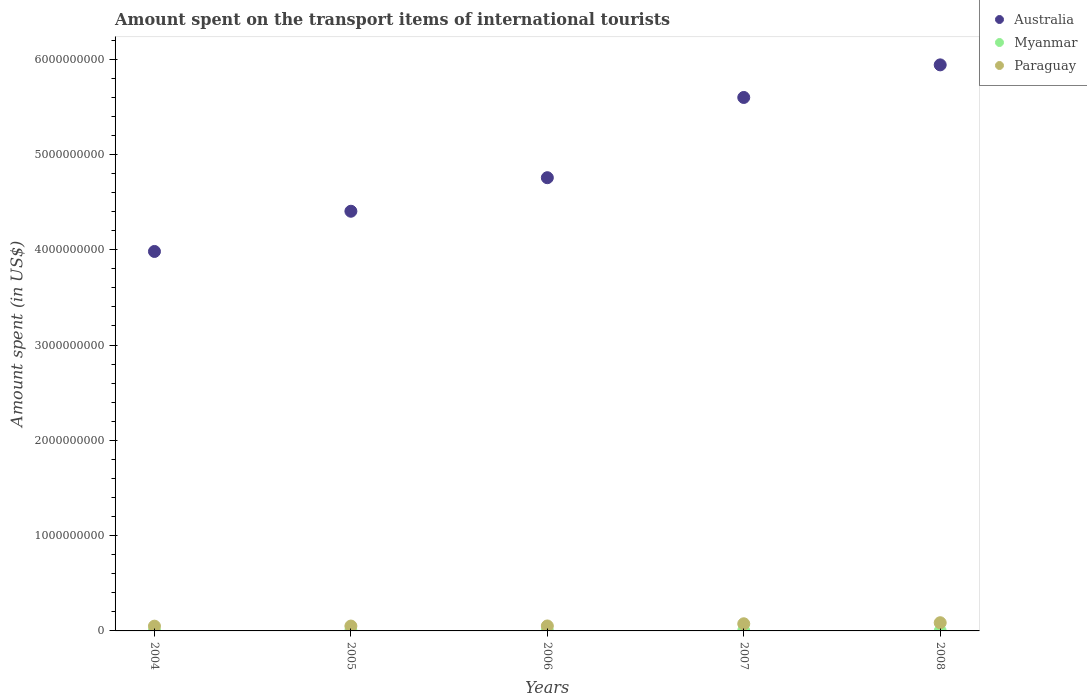In which year was the amount spent on the transport items of international tourists in Australia maximum?
Ensure brevity in your answer.  2008. What is the total amount spent on the transport items of international tourists in Australia in the graph?
Your response must be concise. 2.47e+1. What is the difference between the amount spent on the transport items of international tourists in Australia in 2005 and that in 2007?
Keep it short and to the point. -1.19e+09. What is the difference between the amount spent on the transport items of international tourists in Australia in 2004 and the amount spent on the transport items of international tourists in Paraguay in 2008?
Give a very brief answer. 3.90e+09. What is the average amount spent on the transport items of international tourists in Myanmar per year?
Your response must be concise. 2.54e+06. In the year 2007, what is the difference between the amount spent on the transport items of international tourists in Paraguay and amount spent on the transport items of international tourists in Australia?
Your answer should be very brief. -5.52e+09. In how many years, is the amount spent on the transport items of international tourists in Paraguay greater than 4600000000 US$?
Offer a terse response. 0. What is the ratio of the amount spent on the transport items of international tourists in Myanmar in 2005 to that in 2007?
Make the answer very short. 1. Is the difference between the amount spent on the transport items of international tourists in Paraguay in 2005 and 2007 greater than the difference between the amount spent on the transport items of international tourists in Australia in 2005 and 2007?
Offer a terse response. Yes. What is the difference between the highest and the second highest amount spent on the transport items of international tourists in Australia?
Provide a short and direct response. 3.42e+08. What is the difference between the highest and the lowest amount spent on the transport items of international tourists in Australia?
Provide a short and direct response. 1.96e+09. Is the sum of the amount spent on the transport items of international tourists in Australia in 2005 and 2007 greater than the maximum amount spent on the transport items of international tourists in Myanmar across all years?
Make the answer very short. Yes. How many years are there in the graph?
Keep it short and to the point. 5. What is the difference between two consecutive major ticks on the Y-axis?
Offer a terse response. 1.00e+09. How many legend labels are there?
Make the answer very short. 3. How are the legend labels stacked?
Your response must be concise. Vertical. What is the title of the graph?
Offer a terse response. Amount spent on the transport items of international tourists. What is the label or title of the X-axis?
Keep it short and to the point. Years. What is the label or title of the Y-axis?
Your answer should be very brief. Amount spent (in US$). What is the Amount spent (in US$) of Australia in 2004?
Ensure brevity in your answer.  3.98e+09. What is the Amount spent (in US$) of Australia in 2005?
Keep it short and to the point. 4.40e+09. What is the Amount spent (in US$) in Myanmar in 2005?
Keep it short and to the point. 3.00e+06. What is the Amount spent (in US$) in Paraguay in 2005?
Make the answer very short. 5.10e+07. What is the Amount spent (in US$) of Australia in 2006?
Your answer should be compact. 4.76e+09. What is the Amount spent (in US$) in Paraguay in 2006?
Provide a succinct answer. 5.20e+07. What is the Amount spent (in US$) of Australia in 2007?
Keep it short and to the point. 5.60e+09. What is the Amount spent (in US$) in Paraguay in 2007?
Make the answer very short. 7.50e+07. What is the Amount spent (in US$) of Australia in 2008?
Offer a terse response. 5.94e+09. What is the Amount spent (in US$) of Myanmar in 2008?
Provide a short and direct response. 7.00e+05. What is the Amount spent (in US$) of Paraguay in 2008?
Keep it short and to the point. 8.60e+07. Across all years, what is the maximum Amount spent (in US$) in Australia?
Offer a very short reply. 5.94e+09. Across all years, what is the maximum Amount spent (in US$) in Paraguay?
Offer a terse response. 8.60e+07. Across all years, what is the minimum Amount spent (in US$) in Australia?
Your answer should be very brief. 3.98e+09. Across all years, what is the minimum Amount spent (in US$) of Myanmar?
Your answer should be compact. 7.00e+05. Across all years, what is the minimum Amount spent (in US$) in Paraguay?
Make the answer very short. 5.00e+07. What is the total Amount spent (in US$) of Australia in the graph?
Offer a terse response. 2.47e+1. What is the total Amount spent (in US$) in Myanmar in the graph?
Make the answer very short. 1.27e+07. What is the total Amount spent (in US$) of Paraguay in the graph?
Offer a very short reply. 3.14e+08. What is the difference between the Amount spent (in US$) in Australia in 2004 and that in 2005?
Offer a terse response. -4.22e+08. What is the difference between the Amount spent (in US$) in Myanmar in 2004 and that in 2005?
Ensure brevity in your answer.  0. What is the difference between the Amount spent (in US$) in Australia in 2004 and that in 2006?
Your answer should be compact. -7.74e+08. What is the difference between the Amount spent (in US$) in Myanmar in 2004 and that in 2006?
Offer a very short reply. 0. What is the difference between the Amount spent (in US$) in Australia in 2004 and that in 2007?
Your response must be concise. -1.62e+09. What is the difference between the Amount spent (in US$) of Paraguay in 2004 and that in 2007?
Offer a terse response. -2.50e+07. What is the difference between the Amount spent (in US$) in Australia in 2004 and that in 2008?
Your answer should be compact. -1.96e+09. What is the difference between the Amount spent (in US$) of Myanmar in 2004 and that in 2008?
Offer a terse response. 2.30e+06. What is the difference between the Amount spent (in US$) of Paraguay in 2004 and that in 2008?
Provide a succinct answer. -3.60e+07. What is the difference between the Amount spent (in US$) of Australia in 2005 and that in 2006?
Your answer should be compact. -3.52e+08. What is the difference between the Amount spent (in US$) in Paraguay in 2005 and that in 2006?
Give a very brief answer. -1.00e+06. What is the difference between the Amount spent (in US$) in Australia in 2005 and that in 2007?
Offer a terse response. -1.19e+09. What is the difference between the Amount spent (in US$) of Myanmar in 2005 and that in 2007?
Your answer should be compact. 0. What is the difference between the Amount spent (in US$) in Paraguay in 2005 and that in 2007?
Offer a terse response. -2.40e+07. What is the difference between the Amount spent (in US$) in Australia in 2005 and that in 2008?
Ensure brevity in your answer.  -1.54e+09. What is the difference between the Amount spent (in US$) in Myanmar in 2005 and that in 2008?
Your answer should be compact. 2.30e+06. What is the difference between the Amount spent (in US$) in Paraguay in 2005 and that in 2008?
Ensure brevity in your answer.  -3.50e+07. What is the difference between the Amount spent (in US$) in Australia in 2006 and that in 2007?
Give a very brief answer. -8.42e+08. What is the difference between the Amount spent (in US$) in Myanmar in 2006 and that in 2007?
Offer a terse response. 0. What is the difference between the Amount spent (in US$) in Paraguay in 2006 and that in 2007?
Your answer should be very brief. -2.30e+07. What is the difference between the Amount spent (in US$) in Australia in 2006 and that in 2008?
Make the answer very short. -1.18e+09. What is the difference between the Amount spent (in US$) of Myanmar in 2006 and that in 2008?
Your answer should be compact. 2.30e+06. What is the difference between the Amount spent (in US$) in Paraguay in 2006 and that in 2008?
Provide a short and direct response. -3.40e+07. What is the difference between the Amount spent (in US$) of Australia in 2007 and that in 2008?
Provide a succinct answer. -3.42e+08. What is the difference between the Amount spent (in US$) in Myanmar in 2007 and that in 2008?
Your answer should be compact. 2.30e+06. What is the difference between the Amount spent (in US$) of Paraguay in 2007 and that in 2008?
Keep it short and to the point. -1.10e+07. What is the difference between the Amount spent (in US$) in Australia in 2004 and the Amount spent (in US$) in Myanmar in 2005?
Your response must be concise. 3.98e+09. What is the difference between the Amount spent (in US$) of Australia in 2004 and the Amount spent (in US$) of Paraguay in 2005?
Offer a very short reply. 3.93e+09. What is the difference between the Amount spent (in US$) of Myanmar in 2004 and the Amount spent (in US$) of Paraguay in 2005?
Provide a succinct answer. -4.80e+07. What is the difference between the Amount spent (in US$) of Australia in 2004 and the Amount spent (in US$) of Myanmar in 2006?
Keep it short and to the point. 3.98e+09. What is the difference between the Amount spent (in US$) of Australia in 2004 and the Amount spent (in US$) of Paraguay in 2006?
Provide a short and direct response. 3.93e+09. What is the difference between the Amount spent (in US$) in Myanmar in 2004 and the Amount spent (in US$) in Paraguay in 2006?
Provide a succinct answer. -4.90e+07. What is the difference between the Amount spent (in US$) in Australia in 2004 and the Amount spent (in US$) in Myanmar in 2007?
Offer a very short reply. 3.98e+09. What is the difference between the Amount spent (in US$) of Australia in 2004 and the Amount spent (in US$) of Paraguay in 2007?
Offer a very short reply. 3.91e+09. What is the difference between the Amount spent (in US$) of Myanmar in 2004 and the Amount spent (in US$) of Paraguay in 2007?
Offer a very short reply. -7.20e+07. What is the difference between the Amount spent (in US$) of Australia in 2004 and the Amount spent (in US$) of Myanmar in 2008?
Make the answer very short. 3.98e+09. What is the difference between the Amount spent (in US$) in Australia in 2004 and the Amount spent (in US$) in Paraguay in 2008?
Your response must be concise. 3.90e+09. What is the difference between the Amount spent (in US$) in Myanmar in 2004 and the Amount spent (in US$) in Paraguay in 2008?
Provide a succinct answer. -8.30e+07. What is the difference between the Amount spent (in US$) in Australia in 2005 and the Amount spent (in US$) in Myanmar in 2006?
Offer a very short reply. 4.40e+09. What is the difference between the Amount spent (in US$) in Australia in 2005 and the Amount spent (in US$) in Paraguay in 2006?
Your response must be concise. 4.35e+09. What is the difference between the Amount spent (in US$) in Myanmar in 2005 and the Amount spent (in US$) in Paraguay in 2006?
Your response must be concise. -4.90e+07. What is the difference between the Amount spent (in US$) of Australia in 2005 and the Amount spent (in US$) of Myanmar in 2007?
Your answer should be compact. 4.40e+09. What is the difference between the Amount spent (in US$) in Australia in 2005 and the Amount spent (in US$) in Paraguay in 2007?
Provide a short and direct response. 4.33e+09. What is the difference between the Amount spent (in US$) of Myanmar in 2005 and the Amount spent (in US$) of Paraguay in 2007?
Keep it short and to the point. -7.20e+07. What is the difference between the Amount spent (in US$) in Australia in 2005 and the Amount spent (in US$) in Myanmar in 2008?
Give a very brief answer. 4.40e+09. What is the difference between the Amount spent (in US$) of Australia in 2005 and the Amount spent (in US$) of Paraguay in 2008?
Give a very brief answer. 4.32e+09. What is the difference between the Amount spent (in US$) in Myanmar in 2005 and the Amount spent (in US$) in Paraguay in 2008?
Offer a terse response. -8.30e+07. What is the difference between the Amount spent (in US$) in Australia in 2006 and the Amount spent (in US$) in Myanmar in 2007?
Provide a succinct answer. 4.75e+09. What is the difference between the Amount spent (in US$) of Australia in 2006 and the Amount spent (in US$) of Paraguay in 2007?
Provide a short and direct response. 4.68e+09. What is the difference between the Amount spent (in US$) in Myanmar in 2006 and the Amount spent (in US$) in Paraguay in 2007?
Ensure brevity in your answer.  -7.20e+07. What is the difference between the Amount spent (in US$) in Australia in 2006 and the Amount spent (in US$) in Myanmar in 2008?
Provide a short and direct response. 4.76e+09. What is the difference between the Amount spent (in US$) of Australia in 2006 and the Amount spent (in US$) of Paraguay in 2008?
Give a very brief answer. 4.67e+09. What is the difference between the Amount spent (in US$) in Myanmar in 2006 and the Amount spent (in US$) in Paraguay in 2008?
Provide a short and direct response. -8.30e+07. What is the difference between the Amount spent (in US$) of Australia in 2007 and the Amount spent (in US$) of Myanmar in 2008?
Make the answer very short. 5.60e+09. What is the difference between the Amount spent (in US$) in Australia in 2007 and the Amount spent (in US$) in Paraguay in 2008?
Provide a succinct answer. 5.51e+09. What is the difference between the Amount spent (in US$) of Myanmar in 2007 and the Amount spent (in US$) of Paraguay in 2008?
Keep it short and to the point. -8.30e+07. What is the average Amount spent (in US$) in Australia per year?
Your response must be concise. 4.94e+09. What is the average Amount spent (in US$) in Myanmar per year?
Your answer should be compact. 2.54e+06. What is the average Amount spent (in US$) in Paraguay per year?
Provide a short and direct response. 6.28e+07. In the year 2004, what is the difference between the Amount spent (in US$) of Australia and Amount spent (in US$) of Myanmar?
Give a very brief answer. 3.98e+09. In the year 2004, what is the difference between the Amount spent (in US$) in Australia and Amount spent (in US$) in Paraguay?
Make the answer very short. 3.93e+09. In the year 2004, what is the difference between the Amount spent (in US$) in Myanmar and Amount spent (in US$) in Paraguay?
Give a very brief answer. -4.70e+07. In the year 2005, what is the difference between the Amount spent (in US$) of Australia and Amount spent (in US$) of Myanmar?
Provide a succinct answer. 4.40e+09. In the year 2005, what is the difference between the Amount spent (in US$) in Australia and Amount spent (in US$) in Paraguay?
Keep it short and to the point. 4.35e+09. In the year 2005, what is the difference between the Amount spent (in US$) in Myanmar and Amount spent (in US$) in Paraguay?
Keep it short and to the point. -4.80e+07. In the year 2006, what is the difference between the Amount spent (in US$) of Australia and Amount spent (in US$) of Myanmar?
Provide a short and direct response. 4.75e+09. In the year 2006, what is the difference between the Amount spent (in US$) in Australia and Amount spent (in US$) in Paraguay?
Offer a very short reply. 4.70e+09. In the year 2006, what is the difference between the Amount spent (in US$) of Myanmar and Amount spent (in US$) of Paraguay?
Keep it short and to the point. -4.90e+07. In the year 2007, what is the difference between the Amount spent (in US$) of Australia and Amount spent (in US$) of Myanmar?
Give a very brief answer. 5.60e+09. In the year 2007, what is the difference between the Amount spent (in US$) in Australia and Amount spent (in US$) in Paraguay?
Provide a succinct answer. 5.52e+09. In the year 2007, what is the difference between the Amount spent (in US$) of Myanmar and Amount spent (in US$) of Paraguay?
Ensure brevity in your answer.  -7.20e+07. In the year 2008, what is the difference between the Amount spent (in US$) in Australia and Amount spent (in US$) in Myanmar?
Make the answer very short. 5.94e+09. In the year 2008, what is the difference between the Amount spent (in US$) in Australia and Amount spent (in US$) in Paraguay?
Offer a very short reply. 5.85e+09. In the year 2008, what is the difference between the Amount spent (in US$) in Myanmar and Amount spent (in US$) in Paraguay?
Offer a terse response. -8.53e+07. What is the ratio of the Amount spent (in US$) in Australia in 2004 to that in 2005?
Provide a short and direct response. 0.9. What is the ratio of the Amount spent (in US$) of Myanmar in 2004 to that in 2005?
Make the answer very short. 1. What is the ratio of the Amount spent (in US$) in Paraguay in 2004 to that in 2005?
Offer a terse response. 0.98. What is the ratio of the Amount spent (in US$) in Australia in 2004 to that in 2006?
Your answer should be very brief. 0.84. What is the ratio of the Amount spent (in US$) of Myanmar in 2004 to that in 2006?
Offer a very short reply. 1. What is the ratio of the Amount spent (in US$) in Paraguay in 2004 to that in 2006?
Offer a terse response. 0.96. What is the ratio of the Amount spent (in US$) of Australia in 2004 to that in 2007?
Provide a short and direct response. 0.71. What is the ratio of the Amount spent (in US$) of Myanmar in 2004 to that in 2007?
Give a very brief answer. 1. What is the ratio of the Amount spent (in US$) in Paraguay in 2004 to that in 2007?
Your answer should be compact. 0.67. What is the ratio of the Amount spent (in US$) of Australia in 2004 to that in 2008?
Make the answer very short. 0.67. What is the ratio of the Amount spent (in US$) of Myanmar in 2004 to that in 2008?
Ensure brevity in your answer.  4.29. What is the ratio of the Amount spent (in US$) of Paraguay in 2004 to that in 2008?
Your answer should be compact. 0.58. What is the ratio of the Amount spent (in US$) of Australia in 2005 to that in 2006?
Your response must be concise. 0.93. What is the ratio of the Amount spent (in US$) of Myanmar in 2005 to that in 2006?
Provide a short and direct response. 1. What is the ratio of the Amount spent (in US$) of Paraguay in 2005 to that in 2006?
Give a very brief answer. 0.98. What is the ratio of the Amount spent (in US$) in Australia in 2005 to that in 2007?
Give a very brief answer. 0.79. What is the ratio of the Amount spent (in US$) of Myanmar in 2005 to that in 2007?
Provide a succinct answer. 1. What is the ratio of the Amount spent (in US$) of Paraguay in 2005 to that in 2007?
Offer a terse response. 0.68. What is the ratio of the Amount spent (in US$) of Australia in 2005 to that in 2008?
Keep it short and to the point. 0.74. What is the ratio of the Amount spent (in US$) in Myanmar in 2005 to that in 2008?
Offer a very short reply. 4.29. What is the ratio of the Amount spent (in US$) in Paraguay in 2005 to that in 2008?
Make the answer very short. 0.59. What is the ratio of the Amount spent (in US$) of Australia in 2006 to that in 2007?
Offer a very short reply. 0.85. What is the ratio of the Amount spent (in US$) of Myanmar in 2006 to that in 2007?
Make the answer very short. 1. What is the ratio of the Amount spent (in US$) of Paraguay in 2006 to that in 2007?
Offer a terse response. 0.69. What is the ratio of the Amount spent (in US$) in Australia in 2006 to that in 2008?
Your answer should be compact. 0.8. What is the ratio of the Amount spent (in US$) in Myanmar in 2006 to that in 2008?
Make the answer very short. 4.29. What is the ratio of the Amount spent (in US$) in Paraguay in 2006 to that in 2008?
Keep it short and to the point. 0.6. What is the ratio of the Amount spent (in US$) of Australia in 2007 to that in 2008?
Offer a very short reply. 0.94. What is the ratio of the Amount spent (in US$) of Myanmar in 2007 to that in 2008?
Provide a succinct answer. 4.29. What is the ratio of the Amount spent (in US$) of Paraguay in 2007 to that in 2008?
Offer a terse response. 0.87. What is the difference between the highest and the second highest Amount spent (in US$) in Australia?
Offer a very short reply. 3.42e+08. What is the difference between the highest and the second highest Amount spent (in US$) of Myanmar?
Provide a succinct answer. 0. What is the difference between the highest and the second highest Amount spent (in US$) in Paraguay?
Give a very brief answer. 1.10e+07. What is the difference between the highest and the lowest Amount spent (in US$) in Australia?
Provide a succinct answer. 1.96e+09. What is the difference between the highest and the lowest Amount spent (in US$) in Myanmar?
Offer a very short reply. 2.30e+06. What is the difference between the highest and the lowest Amount spent (in US$) in Paraguay?
Give a very brief answer. 3.60e+07. 